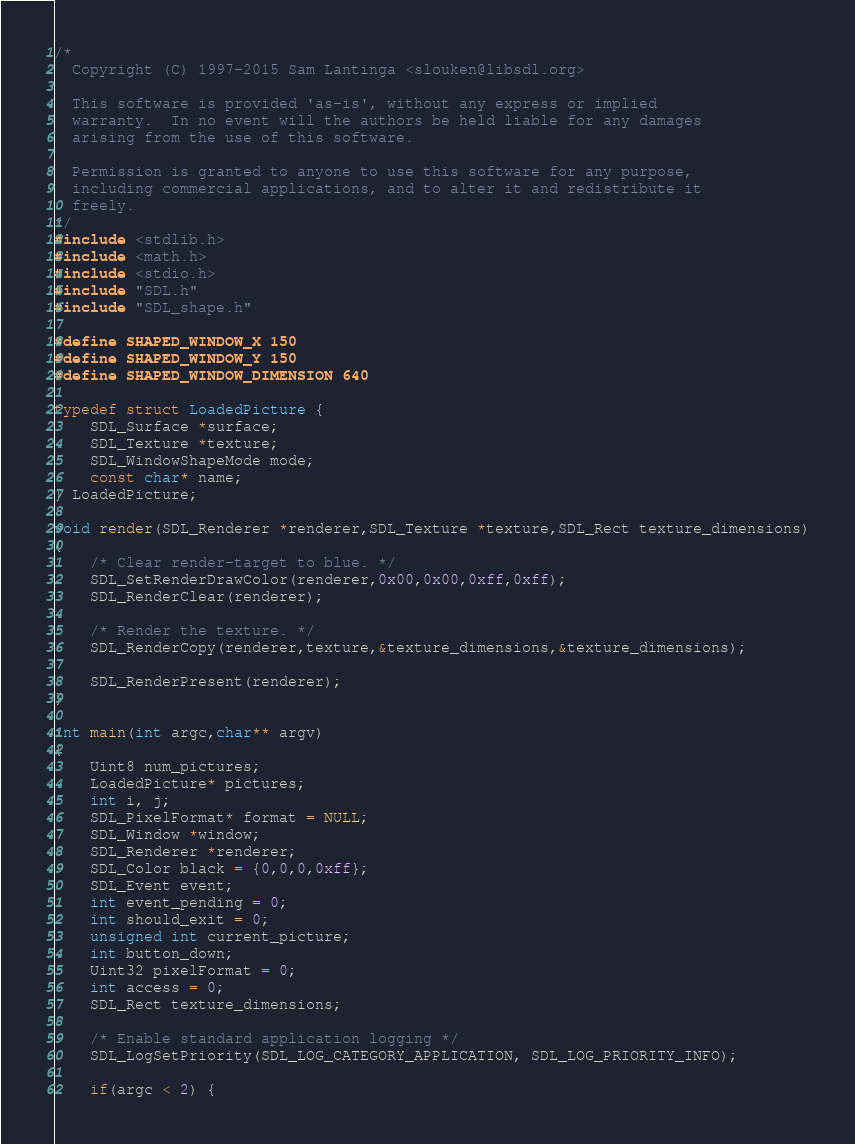<code> <loc_0><loc_0><loc_500><loc_500><_C_>/*
  Copyright (C) 1997-2015 Sam Lantinga <slouken@libsdl.org>

  This software is provided 'as-is', without any express or implied
  warranty.  In no event will the authors be held liable for any damages
  arising from the use of this software.

  Permission is granted to anyone to use this software for any purpose,
  including commercial applications, and to alter it and redistribute it
  freely.
*/
#include <stdlib.h>
#include <math.h>
#include <stdio.h>
#include "SDL.h"
#include "SDL_shape.h"

#define SHAPED_WINDOW_X 150
#define SHAPED_WINDOW_Y 150
#define SHAPED_WINDOW_DIMENSION 640

typedef struct LoadedPicture {
    SDL_Surface *surface;
    SDL_Texture *texture;
    SDL_WindowShapeMode mode;
    const char* name;
} LoadedPicture;

void render(SDL_Renderer *renderer,SDL_Texture *texture,SDL_Rect texture_dimensions)
{
    /* Clear render-target to blue. */
    SDL_SetRenderDrawColor(renderer,0x00,0x00,0xff,0xff);
    SDL_RenderClear(renderer);

    /* Render the texture. */
    SDL_RenderCopy(renderer,texture,&texture_dimensions,&texture_dimensions);

    SDL_RenderPresent(renderer);
}

int main(int argc,char** argv)
{
    Uint8 num_pictures;
    LoadedPicture* pictures;
    int i, j;
    SDL_PixelFormat* format = NULL;
    SDL_Window *window;
    SDL_Renderer *renderer;
    SDL_Color black = {0,0,0,0xff};
    SDL_Event event;
    int event_pending = 0;
    int should_exit = 0;
    unsigned int current_picture;
    int button_down;
    Uint32 pixelFormat = 0;
    int access = 0;
    SDL_Rect texture_dimensions;

    /* Enable standard application logging */
    SDL_LogSetPriority(SDL_LOG_CATEGORY_APPLICATION, SDL_LOG_PRIORITY_INFO);

    if(argc < 2) {</code> 